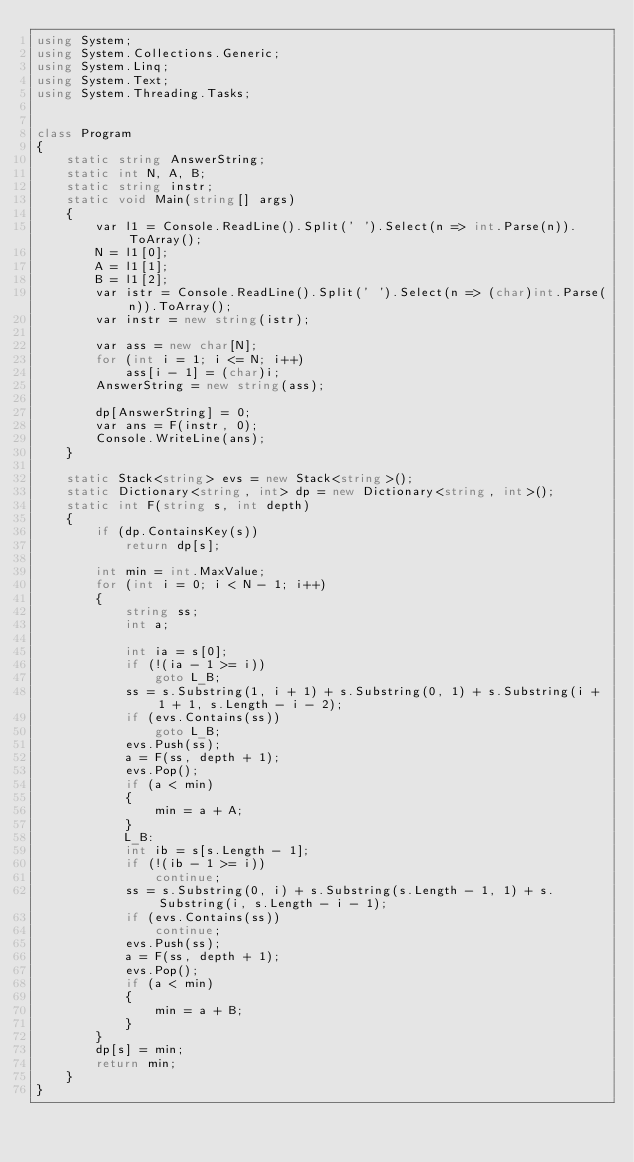Convert code to text. <code><loc_0><loc_0><loc_500><loc_500><_C#_>using System;
using System.Collections.Generic;
using System.Linq;
using System.Text;
using System.Threading.Tasks;


class Program
{
    static string AnswerString;
    static int N, A, B;
    static string instr;
    static void Main(string[] args)
    {
        var l1 = Console.ReadLine().Split(' ').Select(n => int.Parse(n)).ToArray();
        N = l1[0];
        A = l1[1];
        B = l1[2];
        var istr = Console.ReadLine().Split(' ').Select(n => (char)int.Parse(n)).ToArray();
        var instr = new string(istr);

        var ass = new char[N];
        for (int i = 1; i <= N; i++)
            ass[i - 1] = (char)i;
        AnswerString = new string(ass);

        dp[AnswerString] = 0;
        var ans = F(instr, 0);
        Console.WriteLine(ans);
    }

    static Stack<string> evs = new Stack<string>();
    static Dictionary<string, int> dp = new Dictionary<string, int>();
    static int F(string s, int depth)
    {
        if (dp.ContainsKey(s))
            return dp[s];

        int min = int.MaxValue;
        for (int i = 0; i < N - 1; i++)
        {
            string ss;
            int a;

            int ia = s[0];
            if (!(ia - 1 >= i))
                goto L_B;
            ss = s.Substring(1, i + 1) + s.Substring(0, 1) + s.Substring(i + 1 + 1, s.Length - i - 2);
            if (evs.Contains(ss))
                goto L_B;
            evs.Push(ss);
            a = F(ss, depth + 1);
            evs.Pop();
            if (a < min)
            {
                min = a + A;
            }
            L_B:
            int ib = s[s.Length - 1];
            if (!(ib - 1 >= i))
                continue;
            ss = s.Substring(0, i) + s.Substring(s.Length - 1, 1) + s.Substring(i, s.Length - i - 1);
            if (evs.Contains(ss))
                continue;
            evs.Push(ss);
            a = F(ss, depth + 1);
            evs.Pop();
            if (a < min)
            {
                min = a + B;
            }
        }
        dp[s] = min;
        return min;
    }
}
</code> 